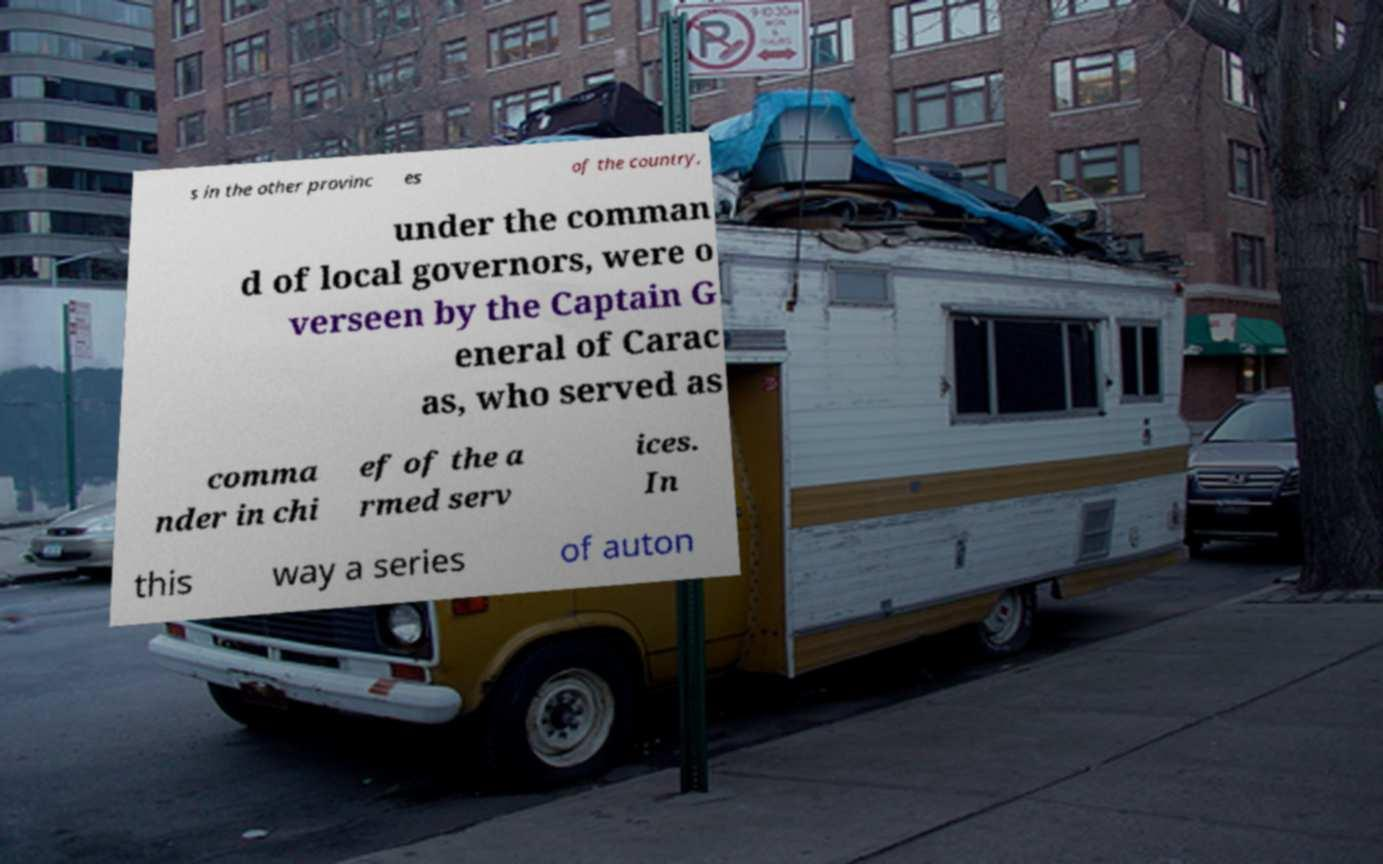Can you read and provide the text displayed in the image?This photo seems to have some interesting text. Can you extract and type it out for me? s in the other provinc es of the country, under the comman d of local governors, were o verseen by the Captain G eneral of Carac as, who served as comma nder in chi ef of the a rmed serv ices. In this way a series of auton 